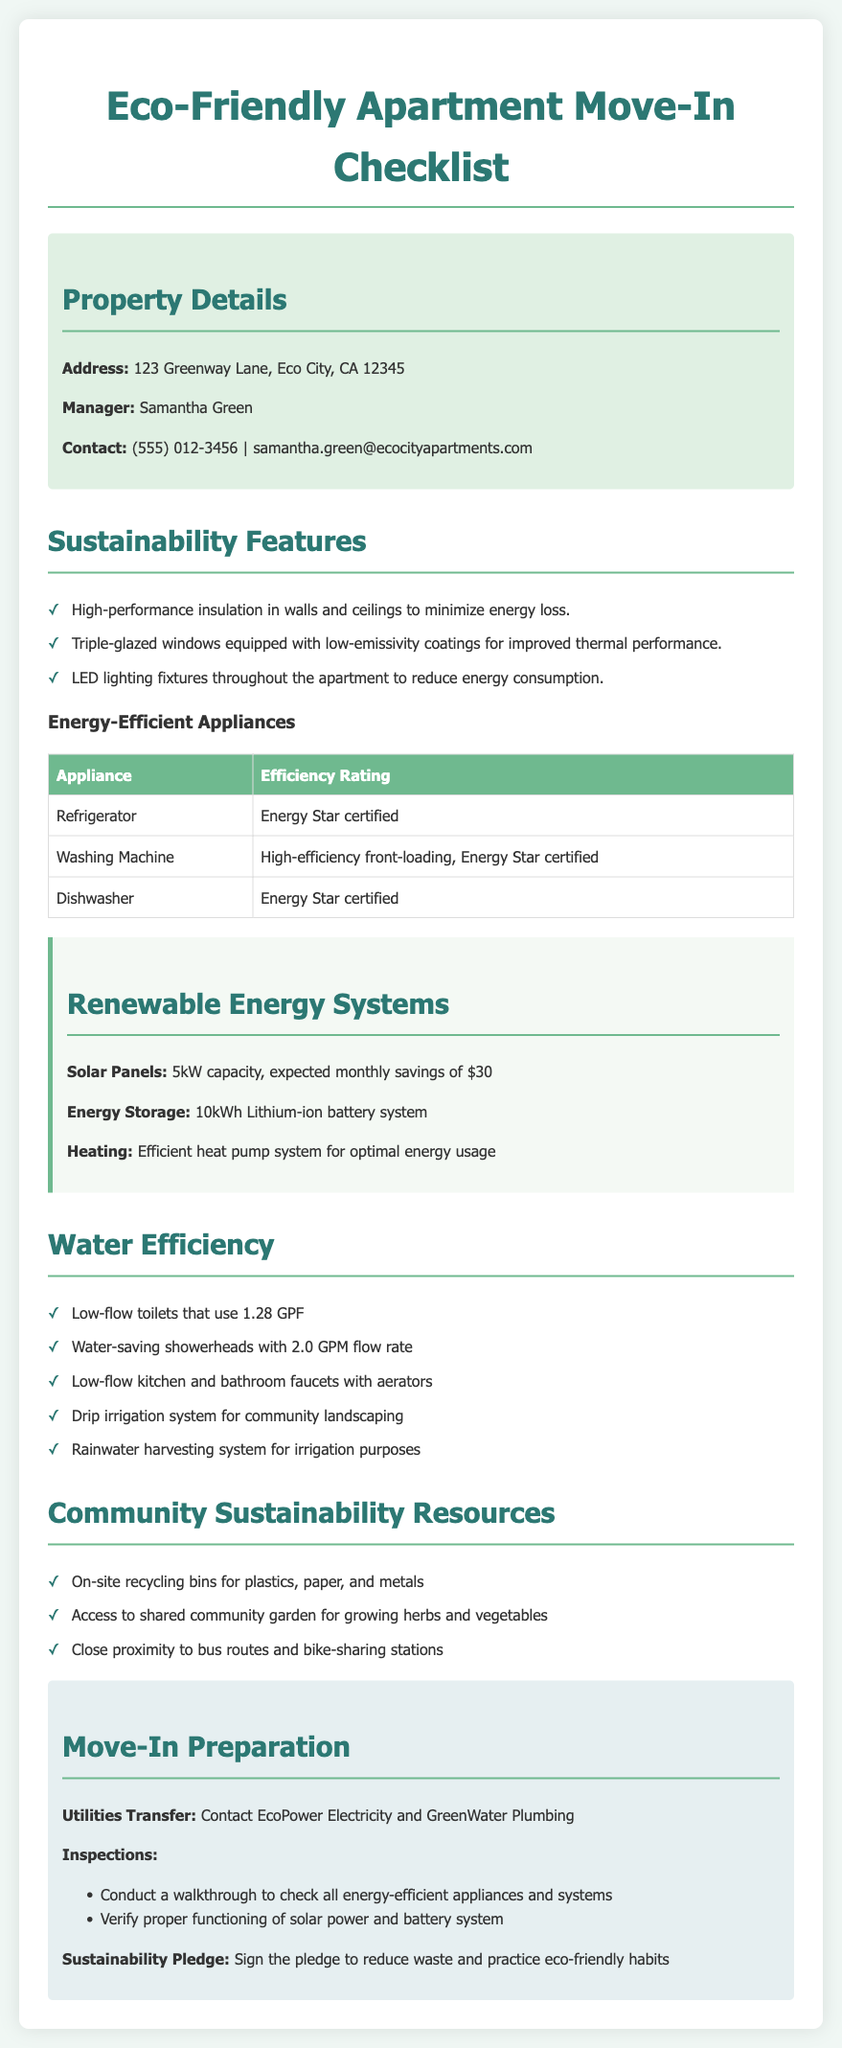what is the address of the apartment? The address is clearly mentioned in the property details section.
Answer: 123 Greenway Lane, Eco City, CA 12345 who is the property manager? The name of the property manager is listed under property details.
Answer: Samantha Green what is the efficiency rating of the refrigerator? The efficiency rating can be found in the table of energy-efficient appliances.
Answer: Energy Star certified how much is the expected monthly savings from the solar panels? This information is stated in the renewable energy systems section.
Answer: $30 what type of battery system is used for energy storage? The type of battery system can be found under renewable energy systems.
Answer: 10kWh Lithium-ion battery system what is one of the water-saving features of the apartment? This detail can be gathered from the water efficiency section.
Answer: Low-flow toilets that use 1.28 GPF how many energy-efficient appliances are mentioned in the document? This involves counting the listed appliances in the table.
Answer: 3 what utility companies need to be contacted for transferring utilities? The utilities transfer section lists the necessary companies.
Answer: EcoPower Electricity and GreenWater Plumbing what sustainability resource is available for growing herbs and vegetables? The community sustainability resources section specifies this feature.
Answer: Shared community garden 